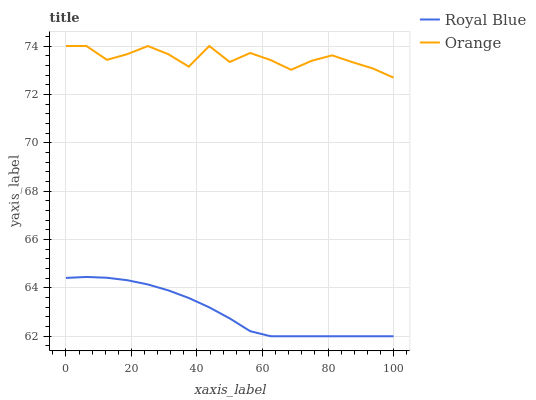Does Royal Blue have the minimum area under the curve?
Answer yes or no. Yes. Does Orange have the maximum area under the curve?
Answer yes or no. Yes. Does Royal Blue have the maximum area under the curve?
Answer yes or no. No. Is Royal Blue the smoothest?
Answer yes or no. Yes. Is Orange the roughest?
Answer yes or no. Yes. Is Royal Blue the roughest?
Answer yes or no. No. Does Royal Blue have the lowest value?
Answer yes or no. Yes. Does Orange have the highest value?
Answer yes or no. Yes. Does Royal Blue have the highest value?
Answer yes or no. No. Is Royal Blue less than Orange?
Answer yes or no. Yes. Is Orange greater than Royal Blue?
Answer yes or no. Yes. Does Royal Blue intersect Orange?
Answer yes or no. No. 